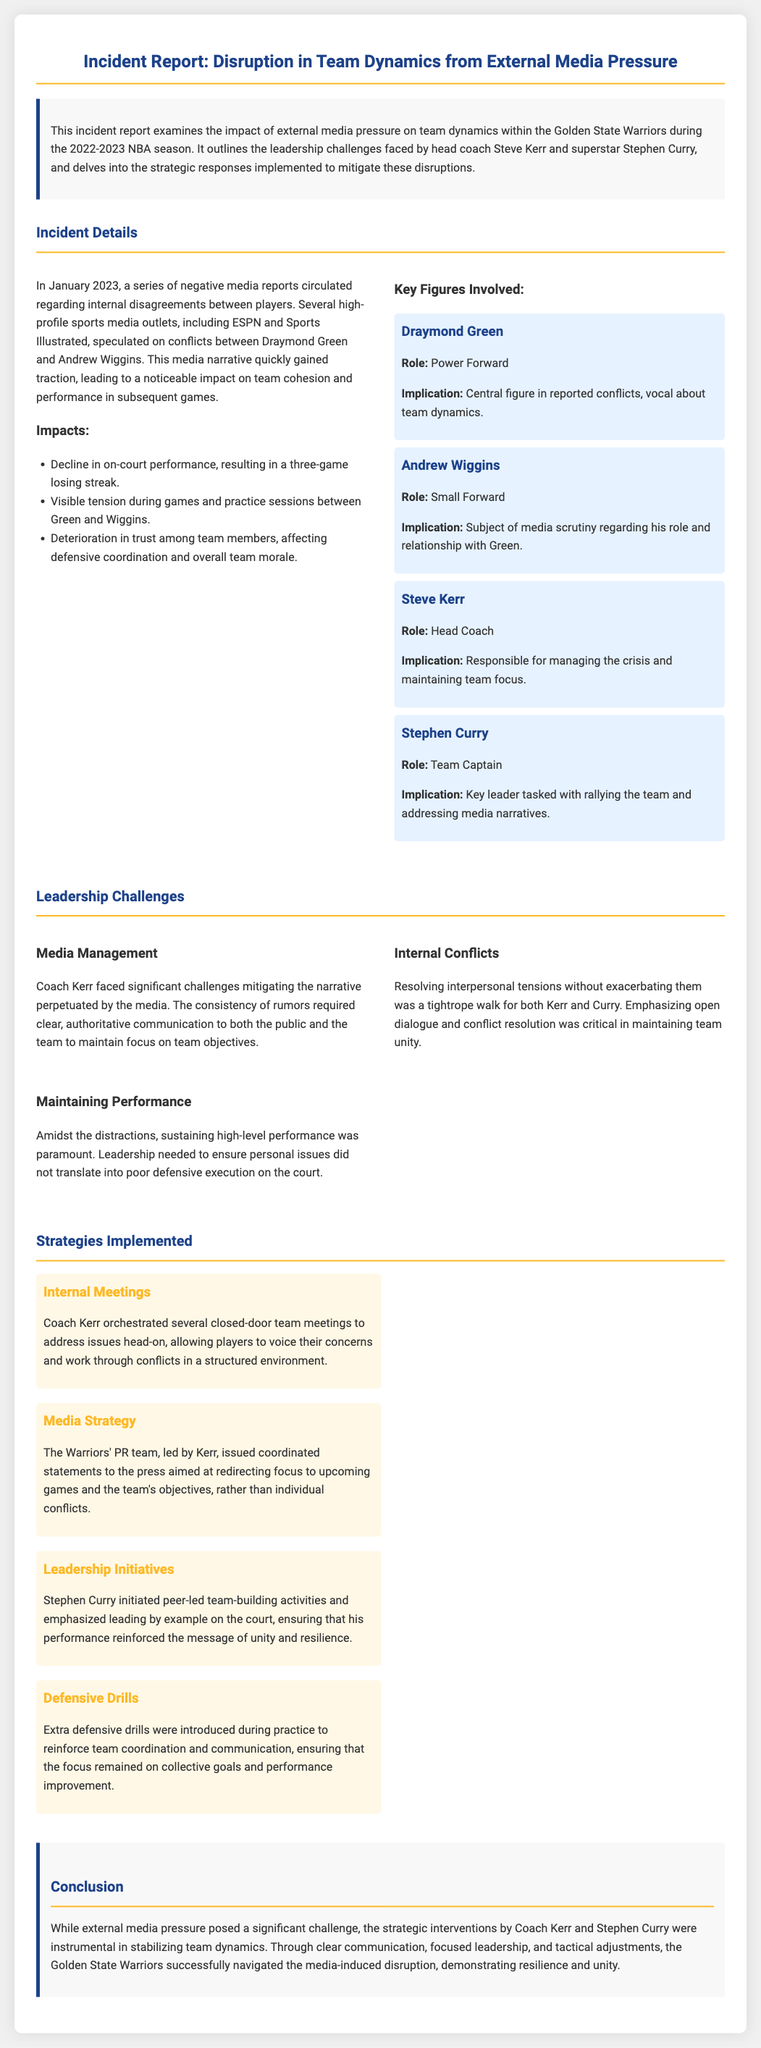What were the media outlets involved? The document lists several high-profile sports media outlets that speculated on team conflicts, including ESPN and Sports Illustrated.
Answer: ESPN and Sports Illustrated When did the incident occur? The report specifies that the incident occurred in January 2023.
Answer: January 2023 Who is the team captain? The key figures section identifies Stephen Curry as the team captain in the incident report.
Answer: Stephen Curry What was one of the impacts on team performance? The report states that there was a decline in on-court performance, specifically mentioning a three-game losing streak.
Answer: Three-game losing streak What type of meetings did Coach Kerr hold? The report mentions that Coach Kerr orchestrated closed-door team meetings to address issues among players.
Answer: Closed-door team meetings Why was maintaining performance challenging? The document explains that distractions from media narratives affected the team's focus on high-level performance.
Answer: Distractions from media narratives What strategy did Stephen Curry initiate? The report states that Stephen Curry initiated peer-led team-building activities to foster unity among players.
Answer: Peer-led team-building activities Which specific drills were introduced to reinforce team coordination? The report mentions that extra defensive drills were introduced during practice for team coordination.
Answer: Extra defensive drills 